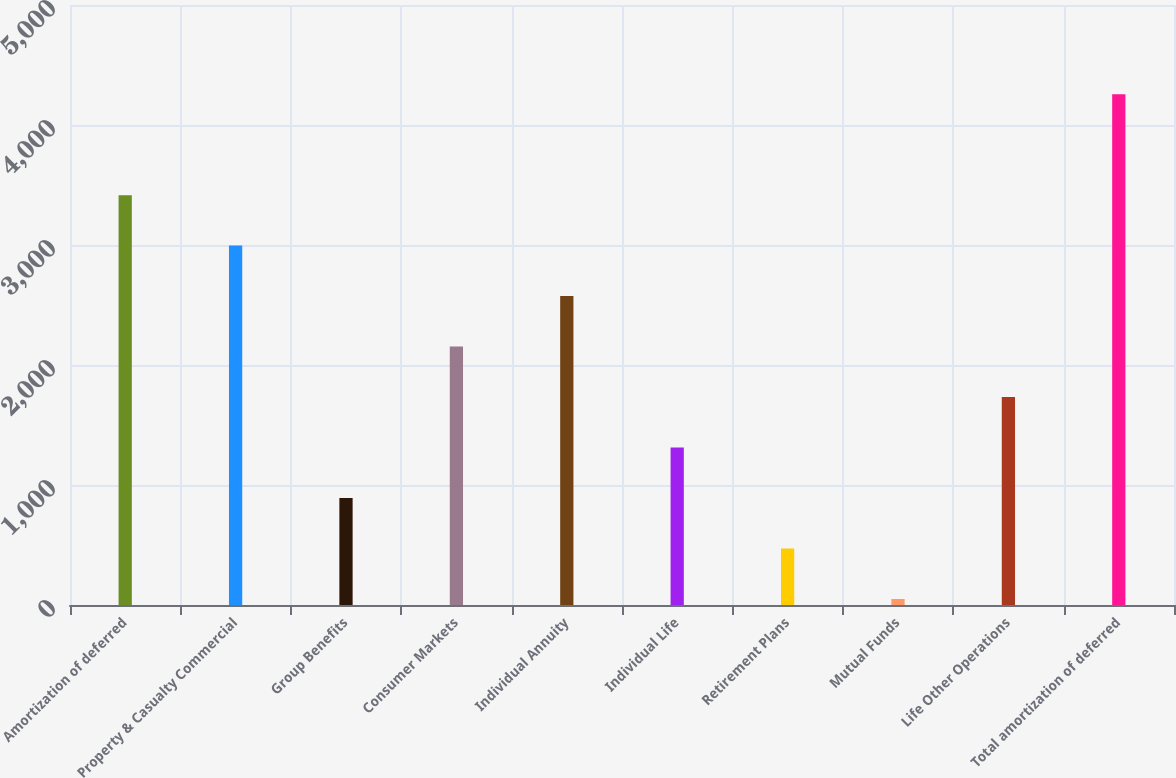Convert chart. <chart><loc_0><loc_0><loc_500><loc_500><bar_chart><fcel>Amortization of deferred<fcel>Property & Casualty Commercial<fcel>Group Benefits<fcel>Consumer Markets<fcel>Individual Annuity<fcel>Individual Life<fcel>Retirement Plans<fcel>Mutual Funds<fcel>Life Other Operations<fcel>Total amortization of deferred<nl><fcel>3415.6<fcel>2994.9<fcel>891.4<fcel>2153.5<fcel>2574.2<fcel>1312.1<fcel>470.7<fcel>50<fcel>1732.8<fcel>4257<nl></chart> 